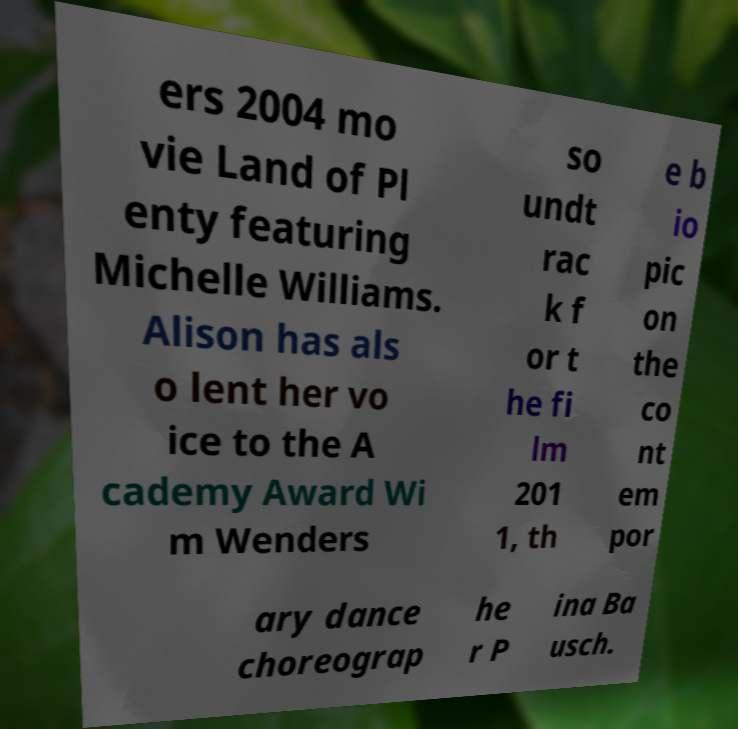Can you read and provide the text displayed in the image?This photo seems to have some interesting text. Can you extract and type it out for me? ers 2004 mo vie Land of Pl enty featuring Michelle Williams. Alison has als o lent her vo ice to the A cademy Award Wi m Wenders so undt rac k f or t he fi lm 201 1, th e b io pic on the co nt em por ary dance choreograp he r P ina Ba usch. 